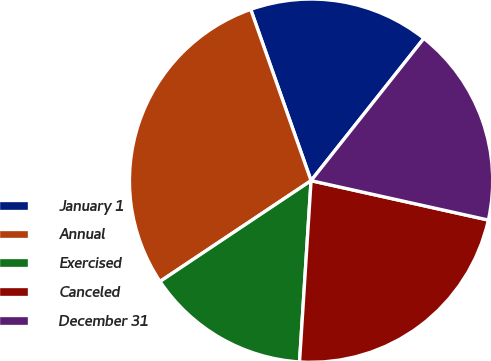Convert chart. <chart><loc_0><loc_0><loc_500><loc_500><pie_chart><fcel>January 1<fcel>Annual<fcel>Exercised<fcel>Canceled<fcel>December 31<nl><fcel>16.06%<fcel>28.97%<fcel>14.62%<fcel>22.53%<fcel>17.81%<nl></chart> 